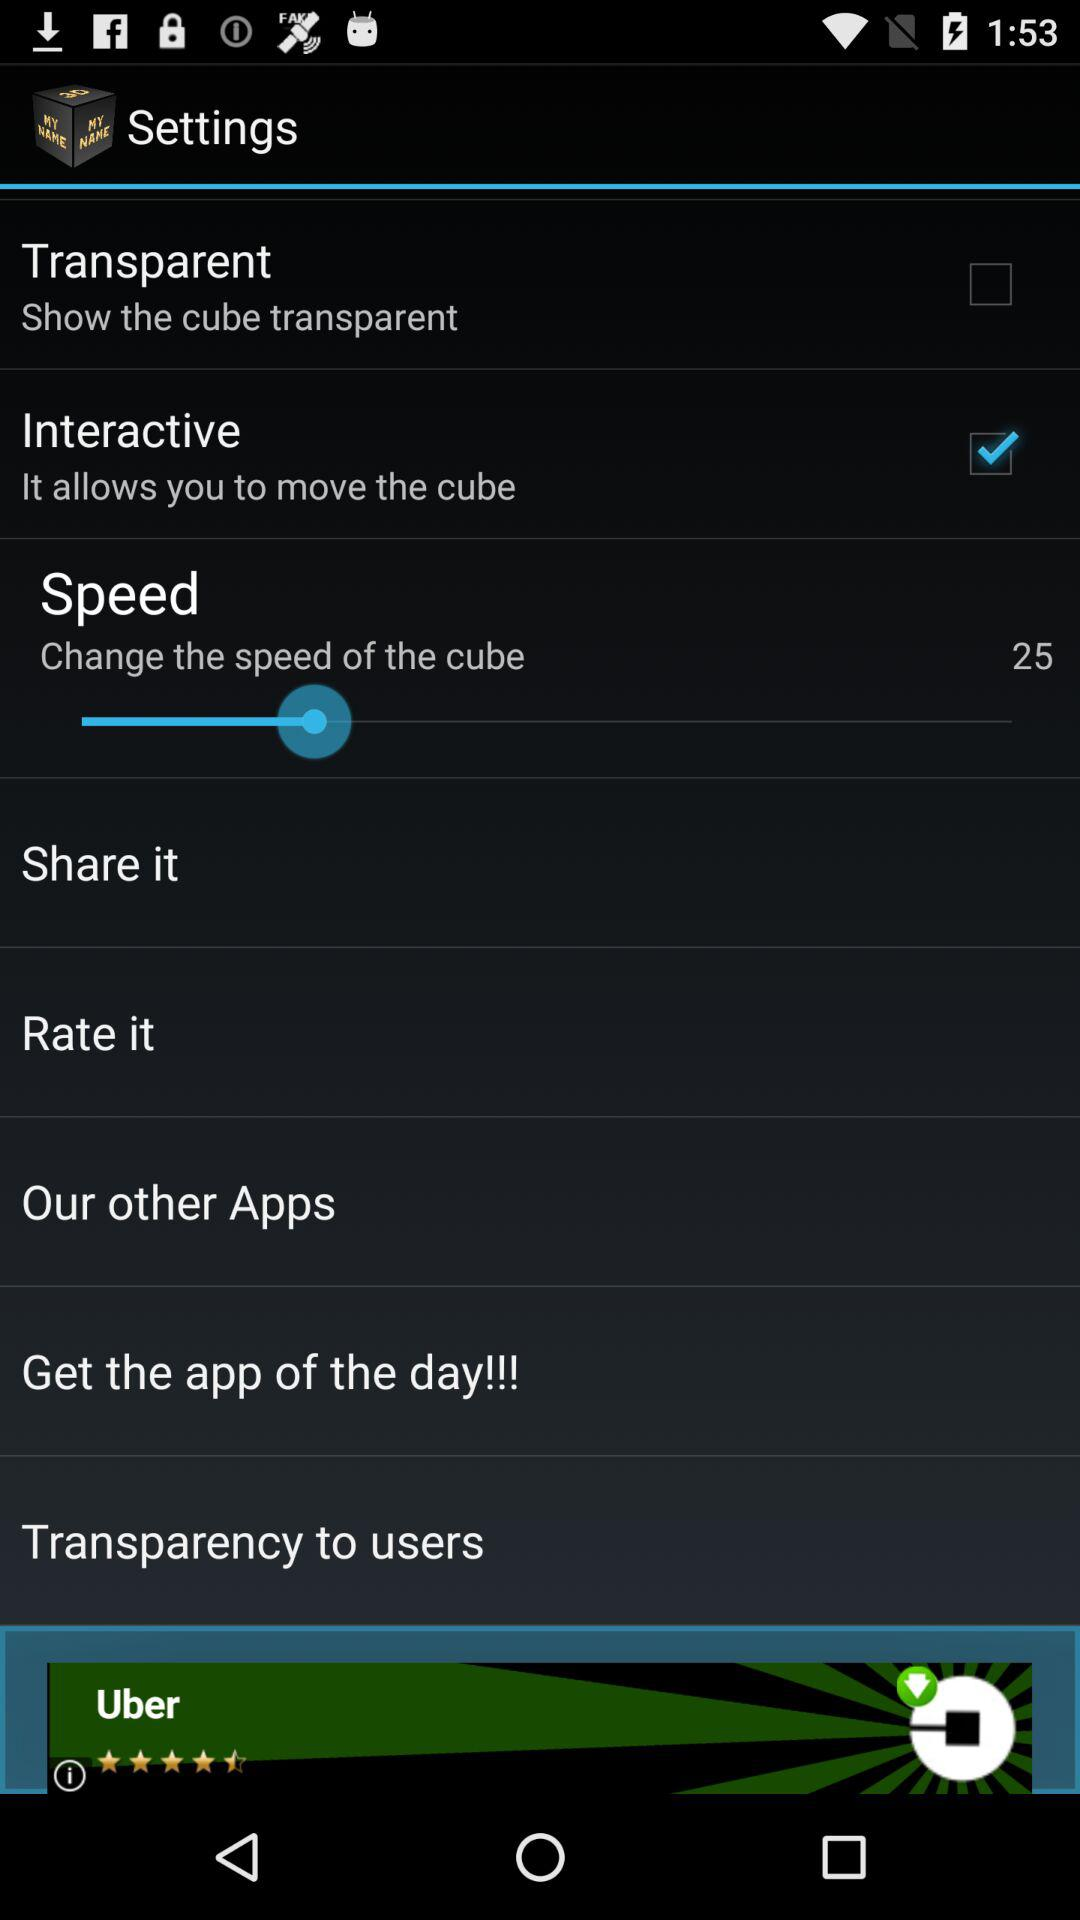Which transparent are shown?
When the provided information is insufficient, respond with <no answer>. <no answer> 